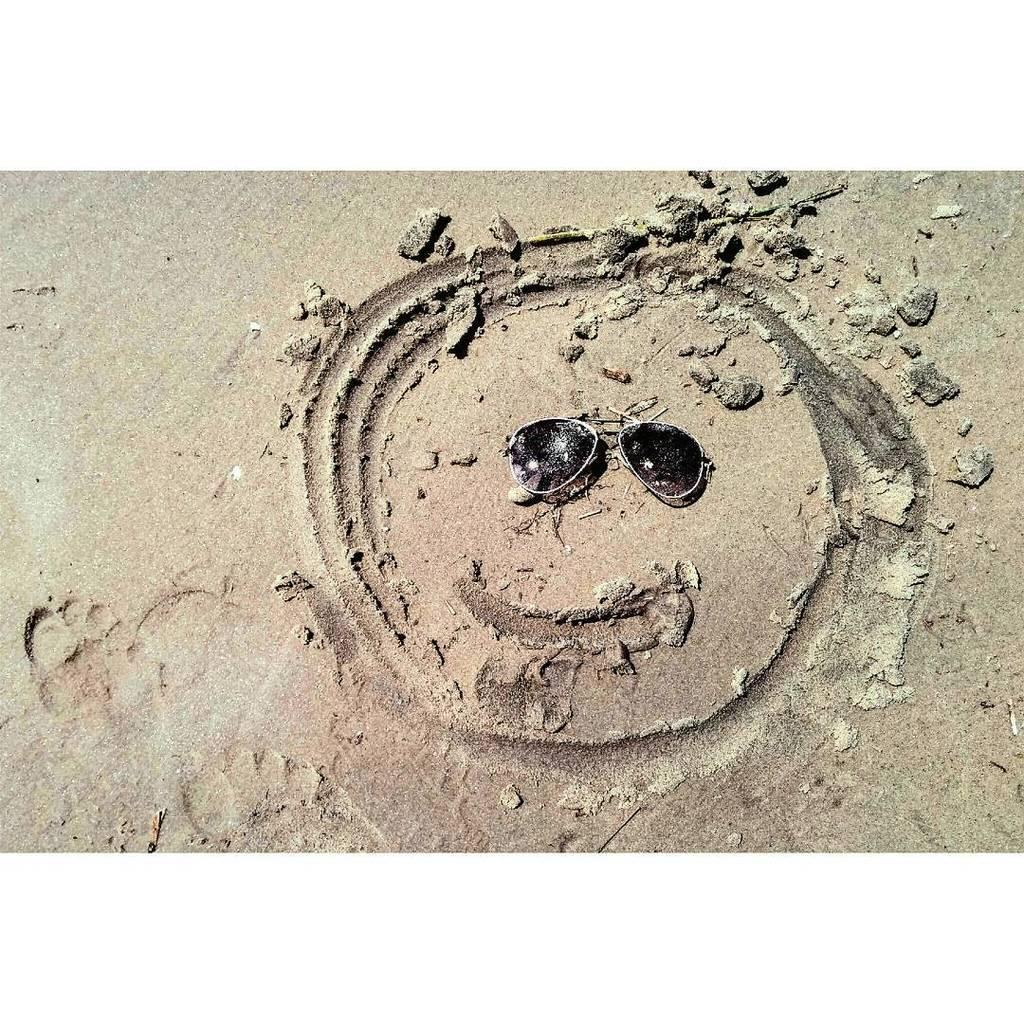What type of art is depicted in the image? The image appears to be a sand art. What objects can be seen in the sand art? There are goggles in the sand art. How many pigs are present in the sand art? There are no pigs present in the sand art; it only features goggles. What type of haircut is shown on the doll in the sand art? There is no doll present in the sand art, only goggles. 